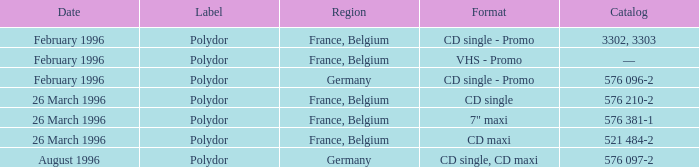Name the catalog for 26 march 1996 576 210-2, 576 381-1, 521 484-2. 